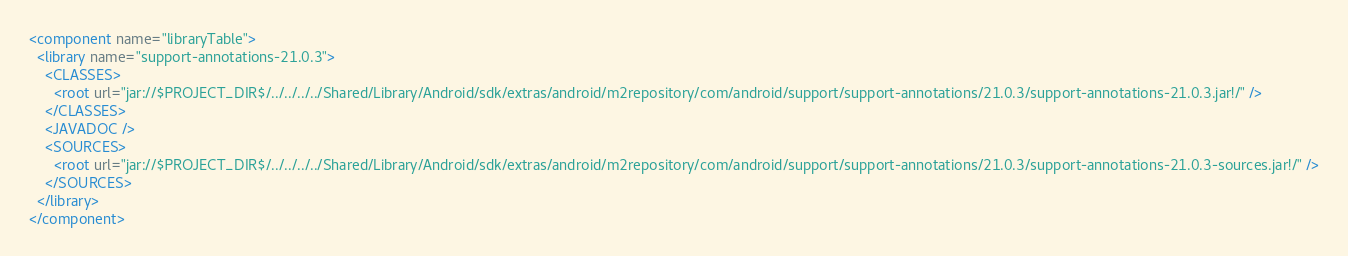Convert code to text. <code><loc_0><loc_0><loc_500><loc_500><_XML_><component name="libraryTable">
  <library name="support-annotations-21.0.3">
    <CLASSES>
      <root url="jar://$PROJECT_DIR$/../../../../Shared/Library/Android/sdk/extras/android/m2repository/com/android/support/support-annotations/21.0.3/support-annotations-21.0.3.jar!/" />
    </CLASSES>
    <JAVADOC />
    <SOURCES>
      <root url="jar://$PROJECT_DIR$/../../../../Shared/Library/Android/sdk/extras/android/m2repository/com/android/support/support-annotations/21.0.3/support-annotations-21.0.3-sources.jar!/" />
    </SOURCES>
  </library>
</component></code> 